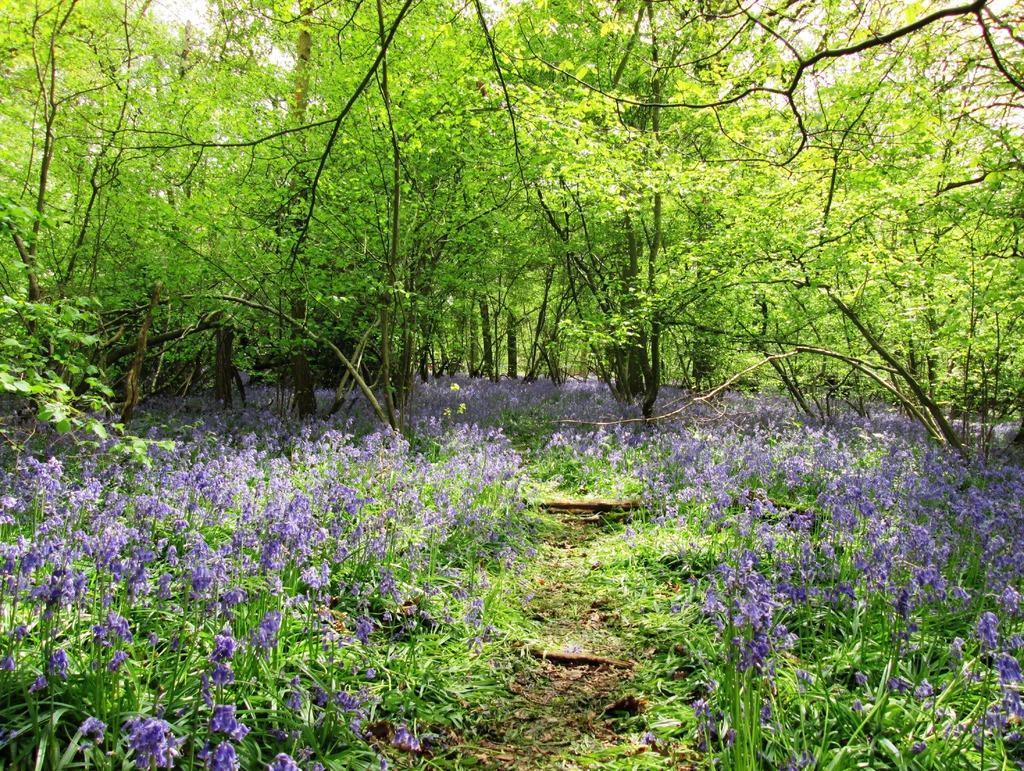How would you summarize this image in a sentence or two? This picture is taken from outside of the city. In this image, we can see some plants with flowers which are in blue color. In the background, we can see some trees, plants. At the top, we can see a sky, at the bottom, we can see a land. 